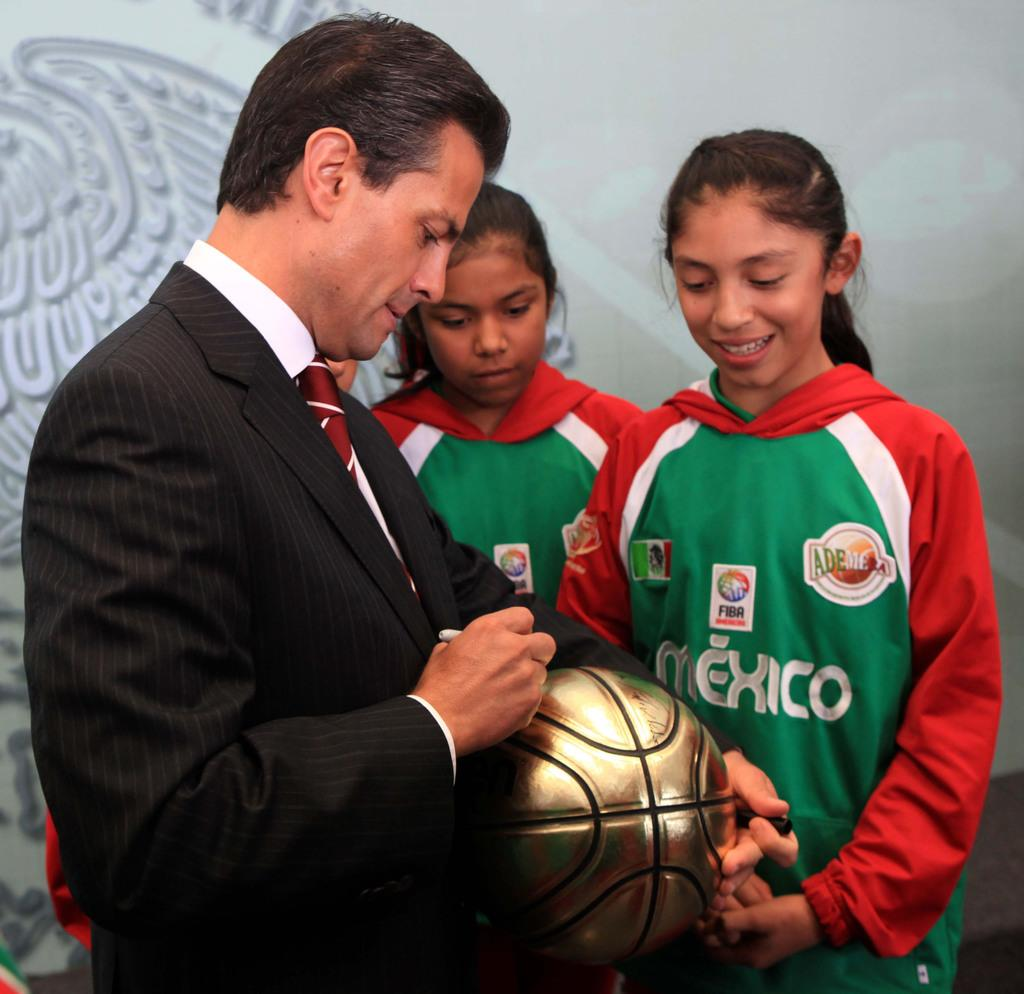What is the color of the wall in the image? The wall in the image is white. How many people are present in the image? There are three people in the image. Can you describe one of the people in the image? One of the people is a man, and he is standing. What is the man holding in the image? The man is holding a ball. What type of bread is the man eating in the image? There is no bread present in the image; the man is holding a ball. 